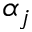Convert formula to latex. <formula><loc_0><loc_0><loc_500><loc_500>\alpha _ { j }</formula> 